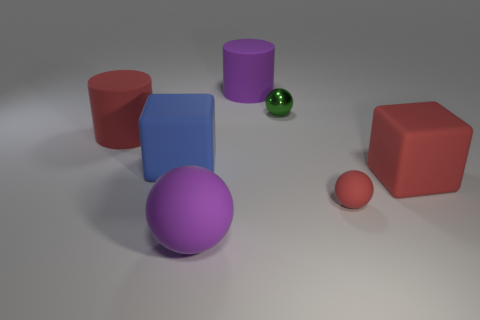Are there any other things that have the same material as the green sphere?
Give a very brief answer. No. There is a tiny metal thing; is it the same color as the matte ball behind the large purple matte ball?
Ensure brevity in your answer.  No. The matte block that is the same size as the blue object is what color?
Your response must be concise. Red. Is there a small yellow thing of the same shape as the blue thing?
Offer a very short reply. No. Is the number of big cyan rubber balls less than the number of red cylinders?
Provide a succinct answer. Yes. What color is the big cylinder that is behind the small metal thing?
Offer a very short reply. Purple. There is a large thing that is to the right of the tiny sphere that is in front of the red cylinder; what is its shape?
Your response must be concise. Cube. Is the small red ball made of the same material as the large thing that is to the right of the tiny metallic thing?
Your response must be concise. Yes. What shape is the object that is the same color as the big matte ball?
Make the answer very short. Cylinder. How many rubber blocks have the same size as the red rubber cylinder?
Give a very brief answer. 2. 